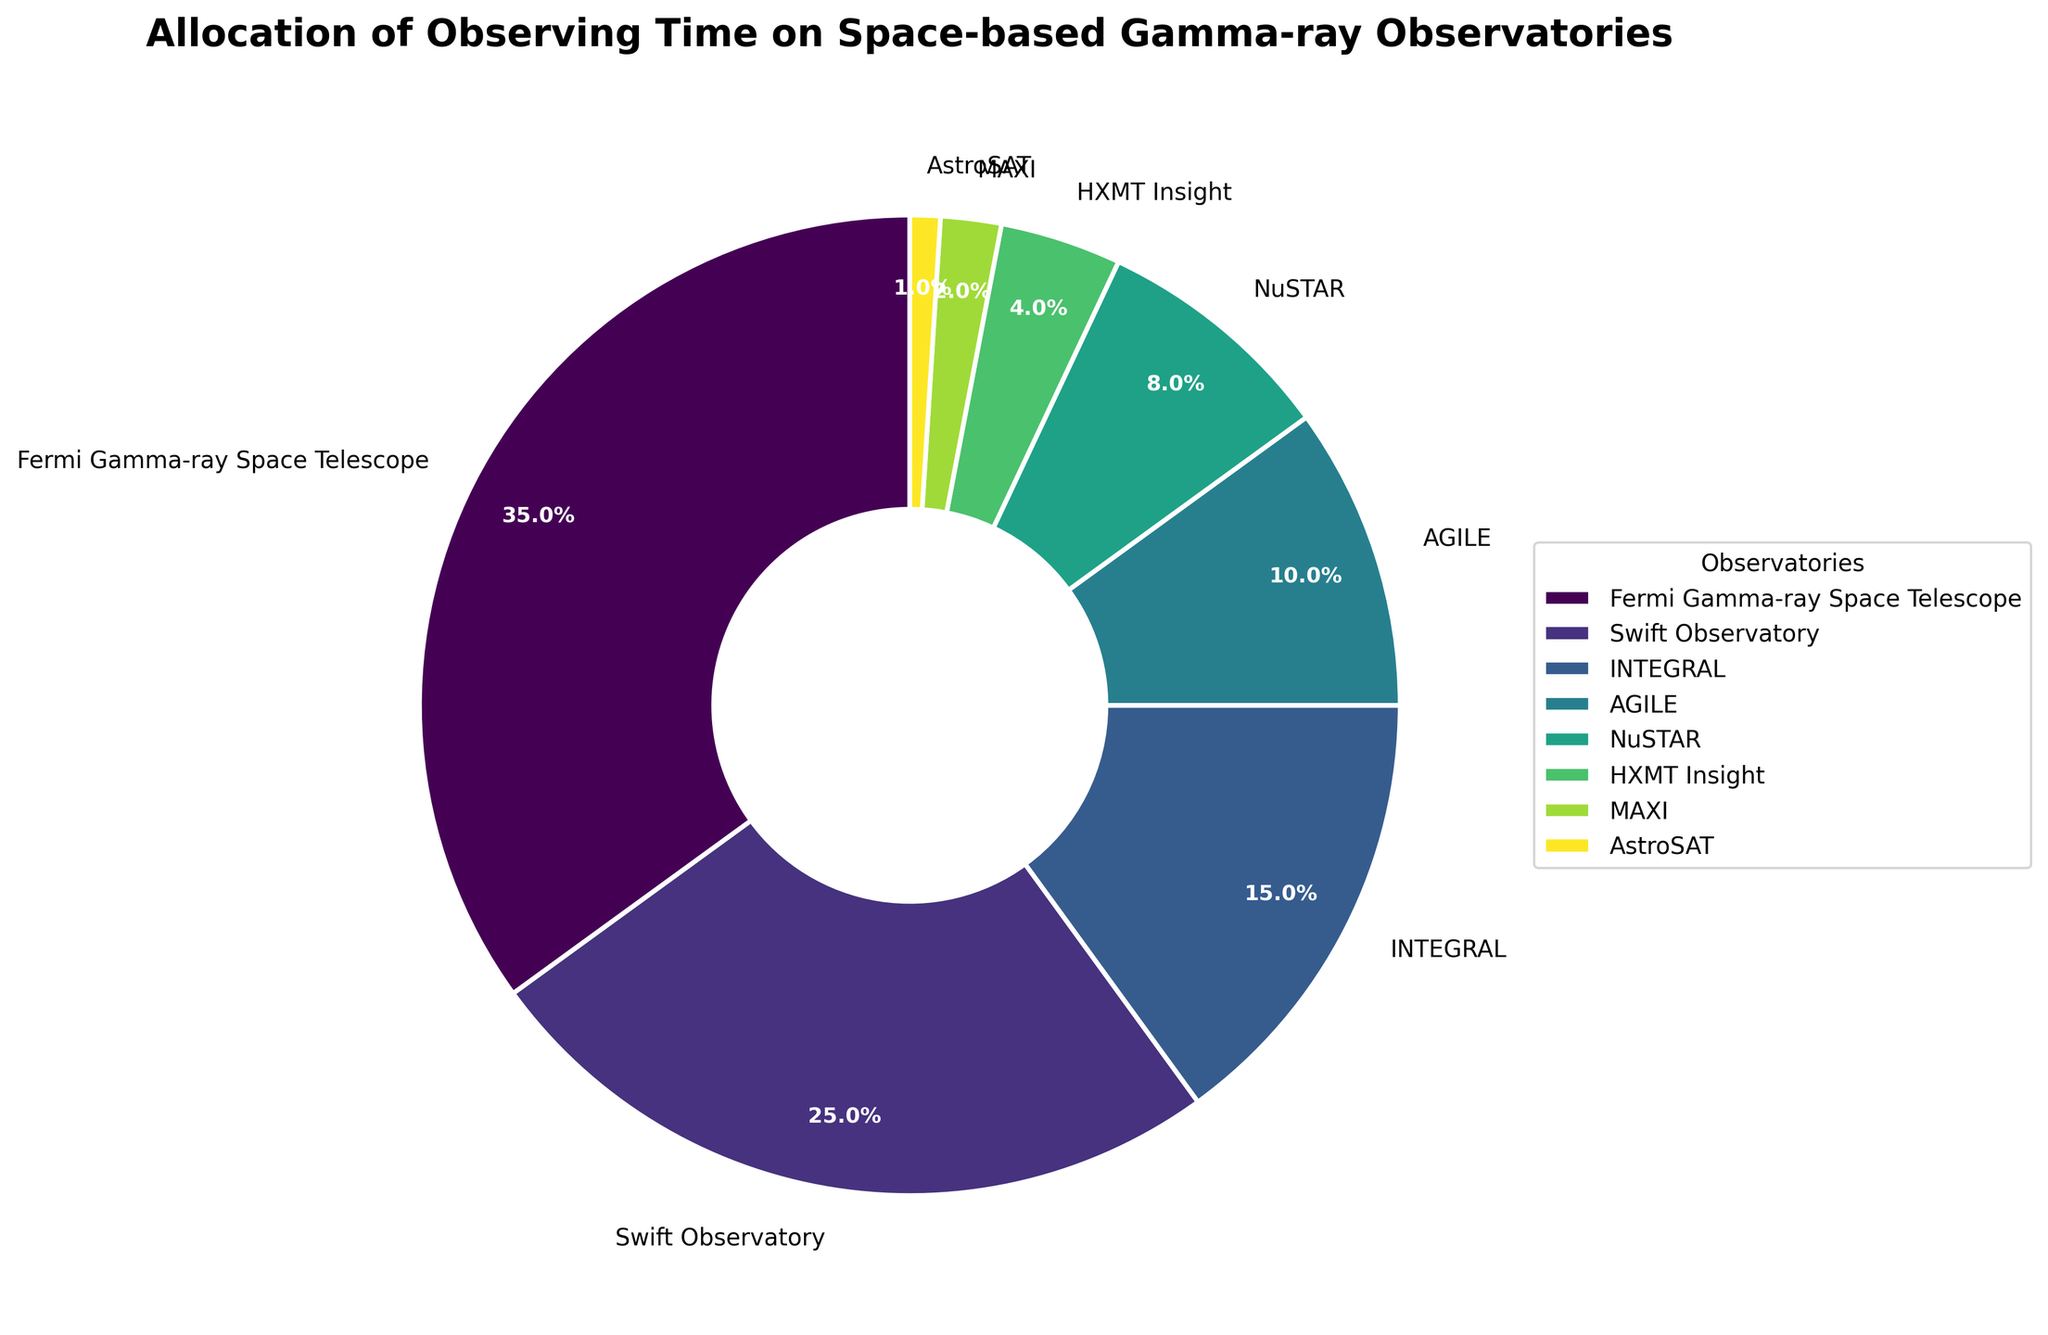What percentage of the observing time is allocated to the Fermi Gamma-ray Space Telescope? The pie chart shows that the Fermi Gamma-ray Space Telescope is allocated 35% of the observing time for GRB studies.
Answer: 35% Which observatory has the least percentage of observing time? According to the pie chart, AstroSAT has the least percentage of observing time, with only 1%.
Answer: AstroSAT What is the combined observing time percentage of the NuSTAR and HXMT Insight observatories? NuSTAR has an 8% allocation and HXMT Insight has a 4% allocation. Adding these together gives 8% + 4% = 12%.
Answer: 12% How does the observing time of the Swift Observatory compare to that of INTEGRAL? The pie chart indicates that the Swift Observatory has 25% of the observing time, whereas INTEGRAL has 15%. Hence, the Swift Observatory has 10% more observing time than INTEGRAL.
Answer: Swift has 10% more What is the total observing time percentage allocated to observatories other than the Fermi Gamma-ray Space Telescope and Swift Observatory combined? The percentages for all observatories except Fermi (35%) and Swift (25%) are: INTEGRAL (15%), AGILE (10%), NuSTAR (8%), HXMT Insight (4%), MAXI (2%), and AstroSAT (1%). Summing these gives 15% + 10% + 8% + 4% + 2% + 1% = 40%.
Answer: 40% Compare the visual sizes of the wedges for AGILE and INTEGRAL. Which one is larger? The pie chart shows that the wedge for INTEGRAL (15%) is larger than that for AGILE (10%).
Answer: INTEGRAL is larger Which color represents the Swift Observatory on the pie chart? When looking at the pie chart, the color representing the Swift Observatory is distinct and can be seen directly from the legend.
Answer: Check the legend What is the difference in observing time allocation between MAXI and HXMT Insight? According to the chart, MAXI is allocated 2% and HXMT Insight is allocated 4%. The difference is 4% - 2% = 2%.
Answer: 2% How much time is allocated to gamma-ray observatories other than Fermi and Swift combined? Summing up the percentages of observatories excluding Fermi (35%) and Swift (25%): INTEGRAL (15%), AGILE (10%), NuSTAR (8%), HXMT Insight (4%), MAXI (2%), AstroSAT (1%) results in: 15% + 10% + 8% + 4% + 2% + 1% = 40%.
Answer: 40% What is the average observing time percentage of all observatories? Summing the percentages: 35% + 25% + 15% + 10% + 8% + 4% + 2% + 1% = 100%. Dividing by the number of observatories (8) gives 100% / 8 = 12.5%.
Answer: 12.5% 